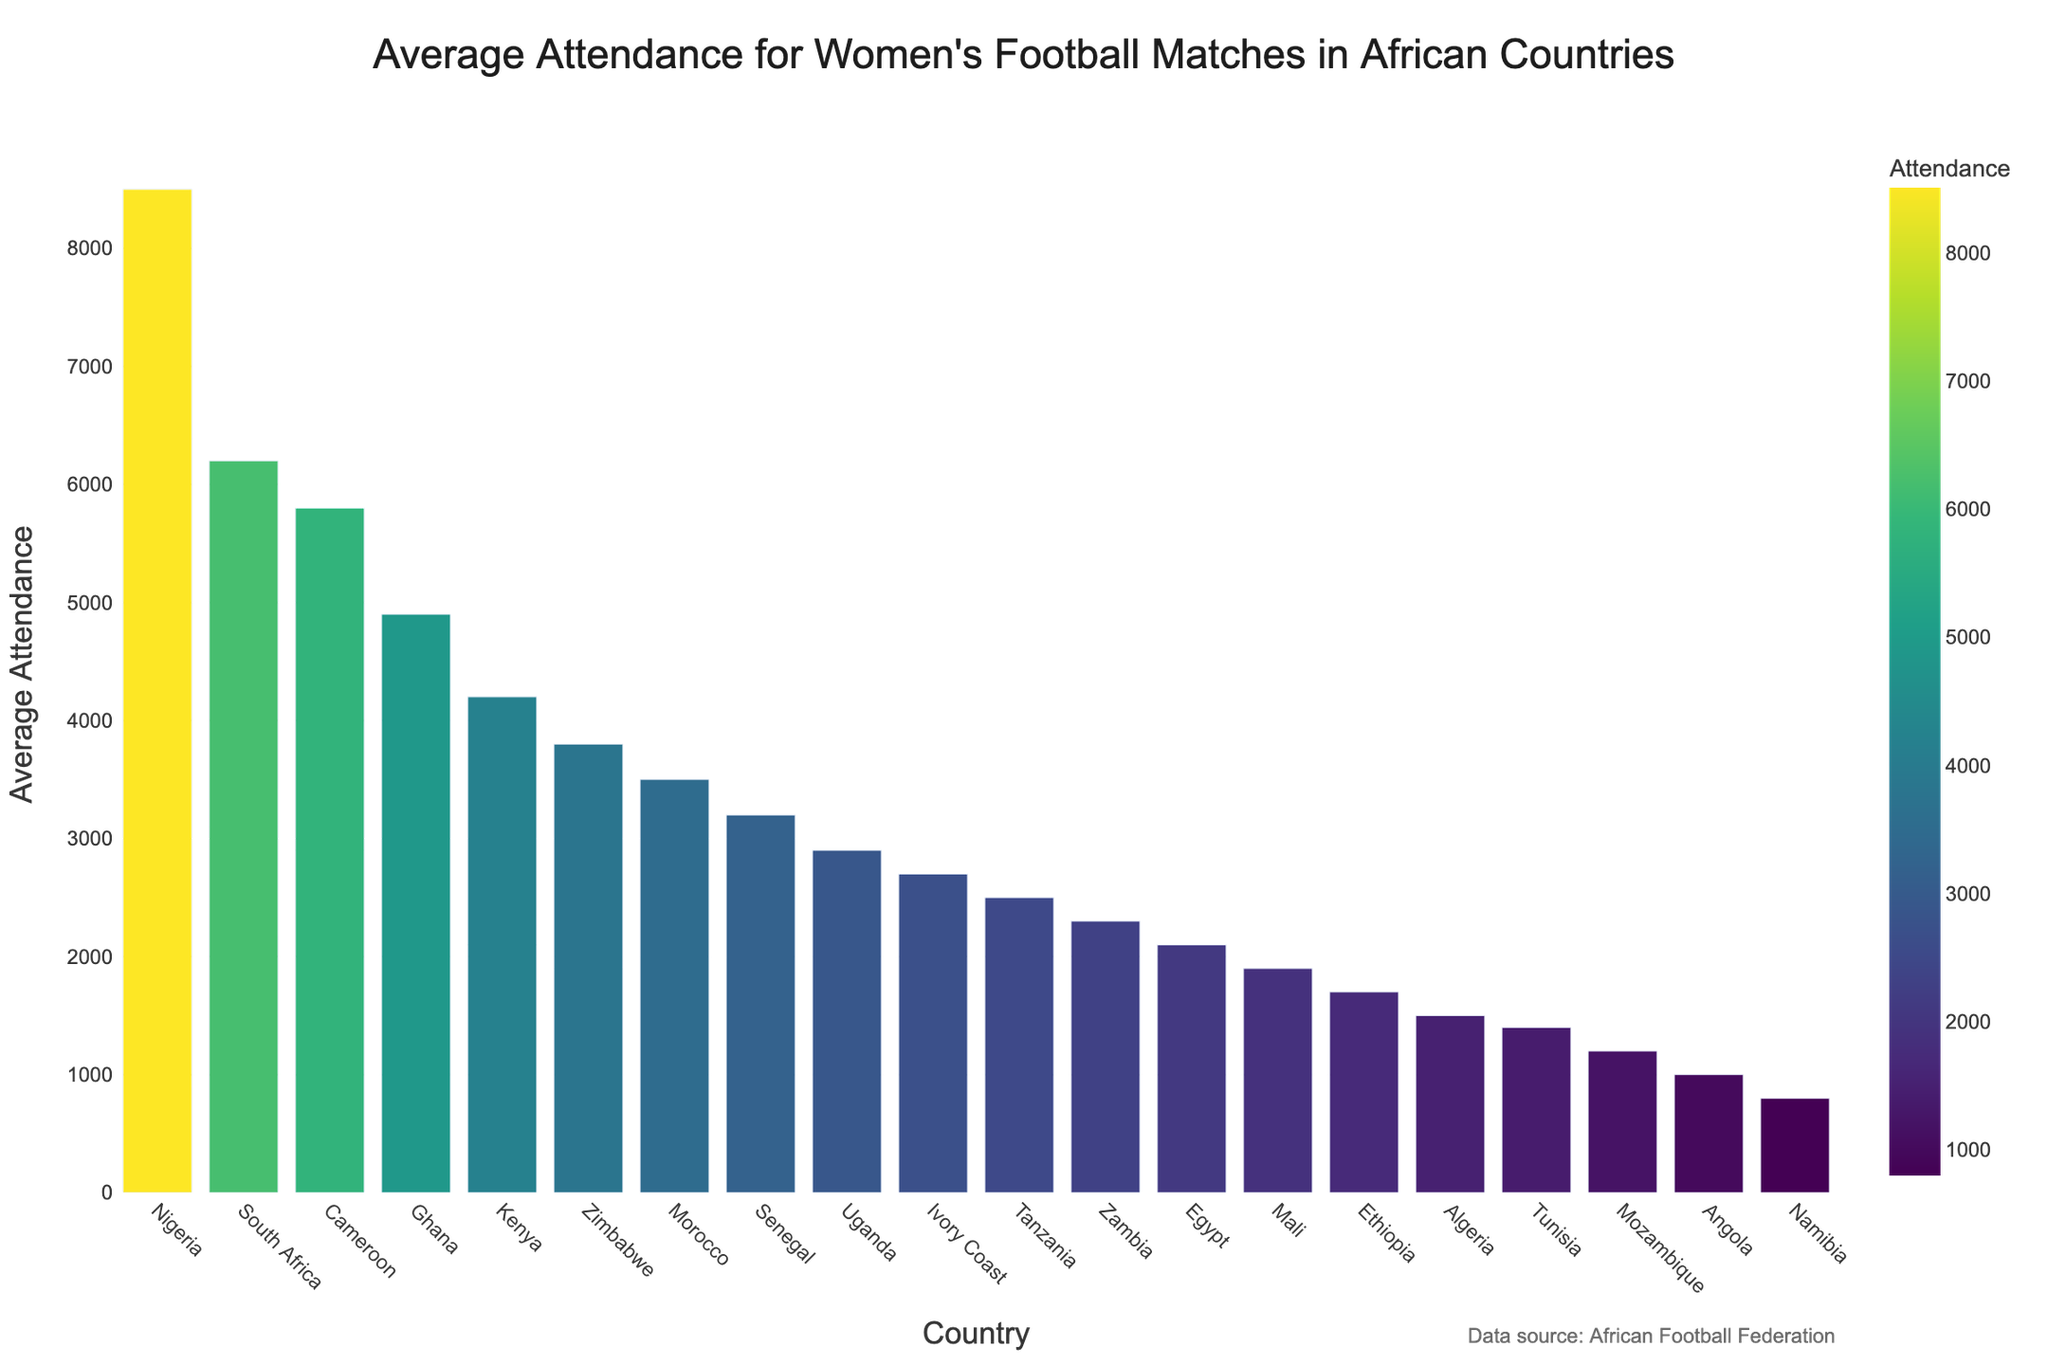Which country has the highest average attendance for women's football matches? Look at the bar chart and identify the bar with the greatest height. This bar corresponds to Nigeria.
Answer: Nigeria Which country has a higher average attendance, Kenya or Zimbabwe? Compare the heights of the bars representing Kenya and Zimbabwe. The bar for Kenya is higher than the bar for Zimbabwe.
Answer: Kenya What is the sum of the average attendances of South Africa, Cameroon, and Ghana? Identify the average attendance for each country: South Africa (6200), Cameroon (5800), and Ghana (4900). Add these values together: 6200 + 5800 + 4900 = 16900.
Answer: 16900 What is the difference in average attendance between Nigeria and Morocco? Find the average attendance for Nigeria (8500) and Morocco (3500). Subtract Morocco's value from Nigeria's: 8500 - 3500 = 5000.
Answer: 5000 Which countries have an average attendance greater than 5000? Identify the bars that extend above the 5000 mark. These countries are Nigeria, South Africa, and Cameroon.
Answer: Nigeria, South Africa, Cameroon How many countries have an average attendance below 2000? Count the number of bars that are below the 2000 mark. These countries are Mali, Ethiopia, Algeria, Tunisia, Mozambique, Angola, and Namibia. Totaling to 7 countries.
Answer: 7 Compare the average attendance of the top three countries. What is their combined average attendance? Identify the top three countries by the heights of the bars: Nigeria (8500), South Africa (6200), and Cameroon (5800). Add these values together: 8500 + 6200 + 5800 = 20500.
Answer: 20500 What is the ratio of the average attendance of Ghana to that of Egypt? Find the average attendance for Ghana (4900) and Egypt (2100). Divide Ghana's value by Egypt's value: 4900 / 2100 ≈ 2.33.
Answer: 2.33 Which African country has the lowest average attendance for women's football matches? Look at the shortest bar, which corresponds to Namibia.
Answer: Namibia Between Zambia and Senegal, which country has a lower average attendance and by how much? Compare the average attendance of Zambia (2300) and Senegal (3200). Zambia has a lower attendance. Calculate the difference: 3200 - 2300 = 900.
Answer: Zambia, 900 